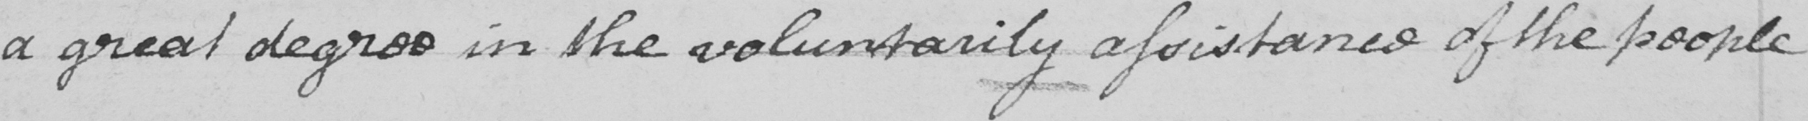Can you read and transcribe this handwriting? a great degree in the vouluntarily assistance of the people 